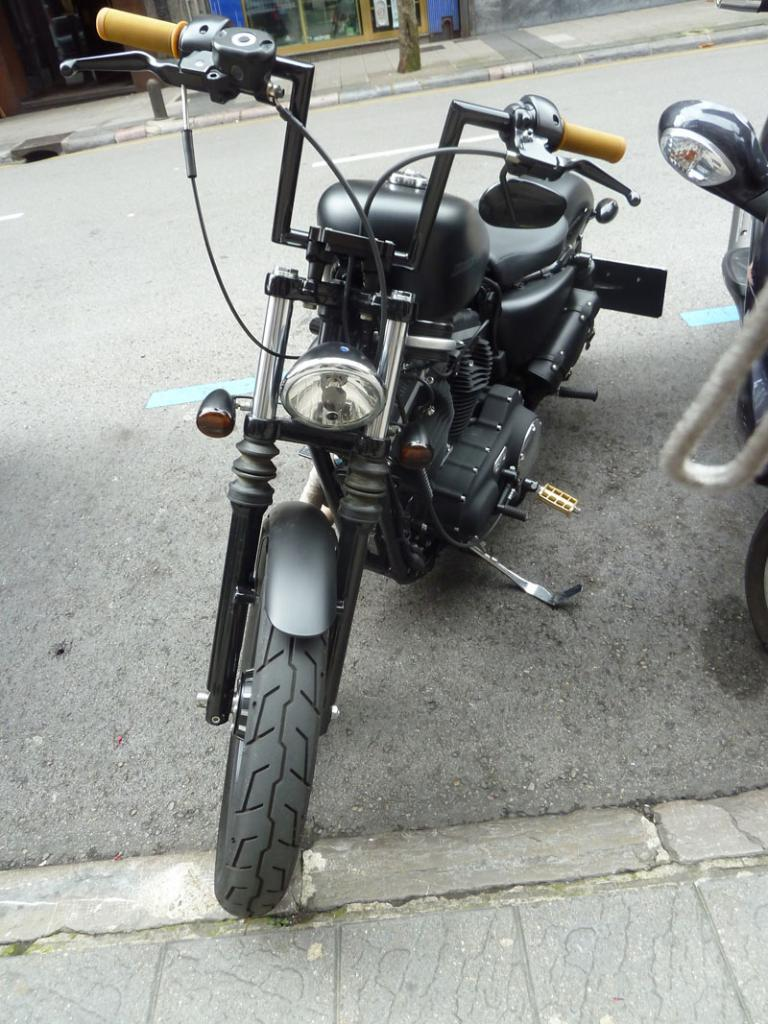What type of vehicles can be seen on the road in the image? There are bikes on the road in the image. What can be seen in the background of the image? There is a tree and a building in the background of the image. What time of day is it in the image, and what flock of birds can be seen flying overhead? The time of day is not mentioned in the image, and there are no birds visible in the image. 